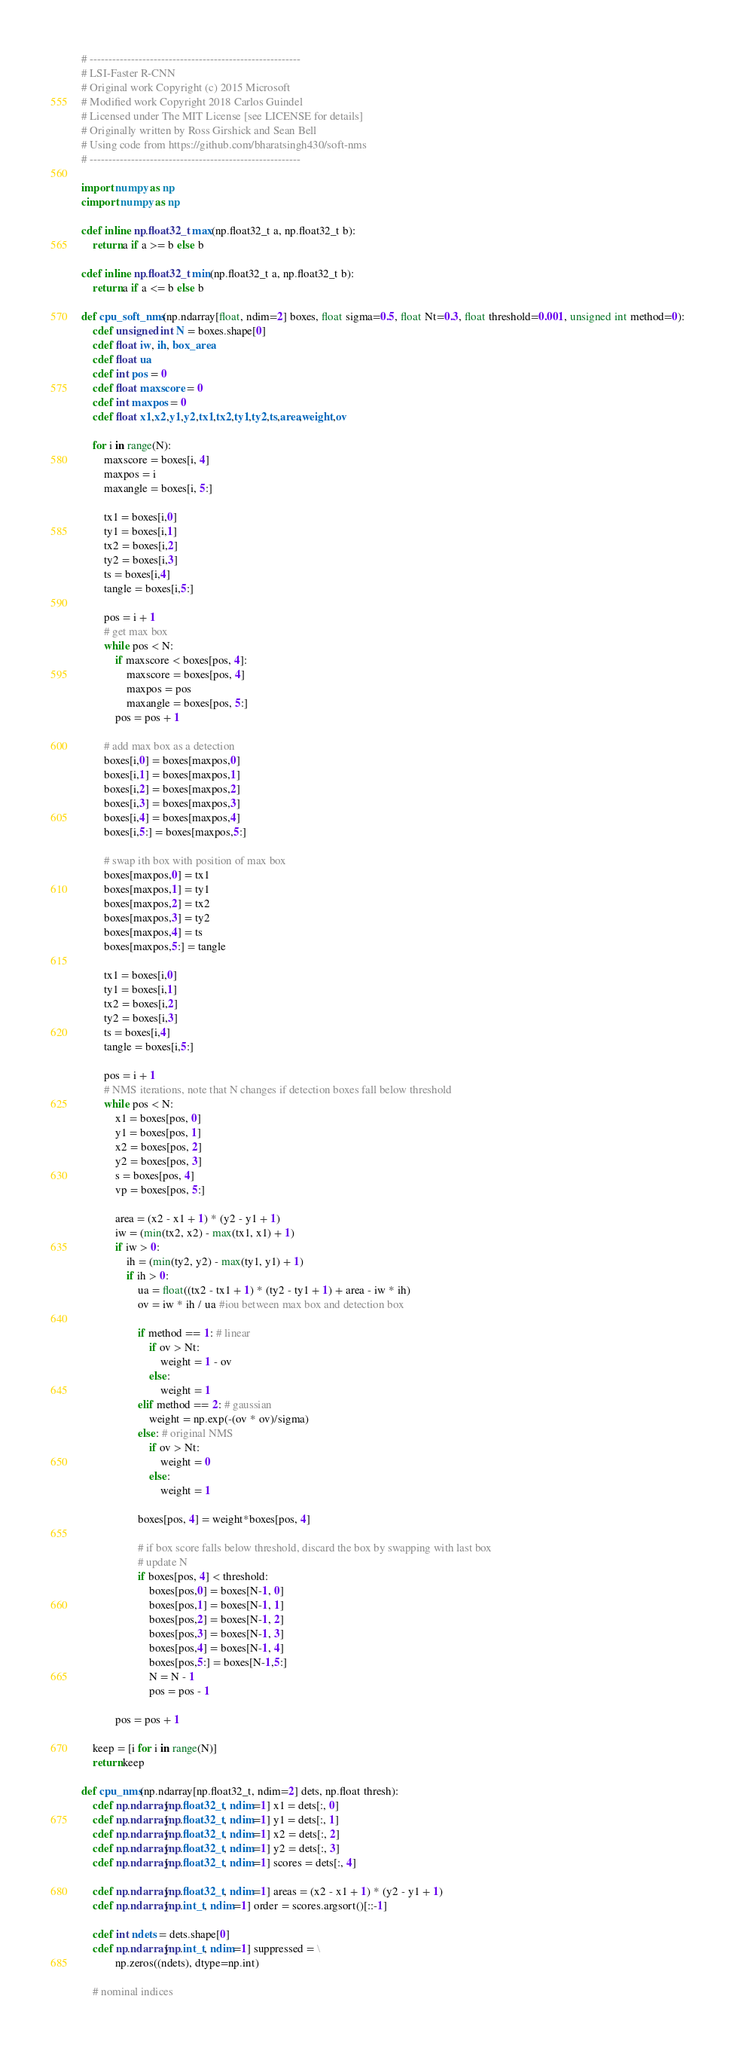<code> <loc_0><loc_0><loc_500><loc_500><_Cython_># --------------------------------------------------------
# LSI-Faster R-CNN
# Original work Copyright (c) 2015 Microsoft
# Modified work Copyright 2018 Carlos Guindel
# Licensed under The MIT License [see LICENSE for details]
# Originally written by Ross Girshick and Sean Bell
# Using code from https://github.com/bharatsingh430/soft-nms
# --------------------------------------------------------

import numpy as np
cimport numpy as np

cdef inline np.float32_t max(np.float32_t a, np.float32_t b):
    return a if a >= b else b

cdef inline np.float32_t min(np.float32_t a, np.float32_t b):
    return a if a <= b else b

def cpu_soft_nms(np.ndarray[float, ndim=2] boxes, float sigma=0.5, float Nt=0.3, float threshold=0.001, unsigned int method=0):
    cdef unsigned int N = boxes.shape[0]
    cdef float iw, ih, box_area
    cdef float ua
    cdef int pos = 0
    cdef float maxscore = 0
    cdef int maxpos = 0
    cdef float x1,x2,y1,y2,tx1,tx2,ty1,ty2,ts,area,weight,ov

    for i in range(N):
        maxscore = boxes[i, 4]
        maxpos = i
        maxangle = boxes[i, 5:]

        tx1 = boxes[i,0]
        ty1 = boxes[i,1]
        tx2 = boxes[i,2]
        ty2 = boxes[i,3]
        ts = boxes[i,4]
        tangle = boxes[i,5:]

        pos = i + 1
        # get max box
        while pos < N:
            if maxscore < boxes[pos, 4]:
                maxscore = boxes[pos, 4]
                maxpos = pos
                maxangle = boxes[pos, 5:]
            pos = pos + 1

        # add max box as a detection
        boxes[i,0] = boxes[maxpos,0]
        boxes[i,1] = boxes[maxpos,1]
        boxes[i,2] = boxes[maxpos,2]
        boxes[i,3] = boxes[maxpos,3]
        boxes[i,4] = boxes[maxpos,4]
        boxes[i,5:] = boxes[maxpos,5:]

        # swap ith box with position of max box
        boxes[maxpos,0] = tx1
        boxes[maxpos,1] = ty1
        boxes[maxpos,2] = tx2
        boxes[maxpos,3] = ty2
        boxes[maxpos,4] = ts
        boxes[maxpos,5:] = tangle

        tx1 = boxes[i,0]
        ty1 = boxes[i,1]
        tx2 = boxes[i,2]
        ty2 = boxes[i,3]
        ts = boxes[i,4]
        tangle = boxes[i,5:]

        pos = i + 1
        # NMS iterations, note that N changes if detection boxes fall below threshold
        while pos < N:
            x1 = boxes[pos, 0]
            y1 = boxes[pos, 1]
            x2 = boxes[pos, 2]
            y2 = boxes[pos, 3]
            s = boxes[pos, 4]
            vp = boxes[pos, 5:]

            area = (x2 - x1 + 1) * (y2 - y1 + 1)
            iw = (min(tx2, x2) - max(tx1, x1) + 1)
            if iw > 0:
                ih = (min(ty2, y2) - max(ty1, y1) + 1)
                if ih > 0:
                    ua = float((tx2 - tx1 + 1) * (ty2 - ty1 + 1) + area - iw * ih)
                    ov = iw * ih / ua #iou between max box and detection box

                    if method == 1: # linear
                        if ov > Nt:
                            weight = 1 - ov
                        else:
                            weight = 1
                    elif method == 2: # gaussian
                        weight = np.exp(-(ov * ov)/sigma)
                    else: # original NMS
                        if ov > Nt:
                            weight = 0
                        else:
                            weight = 1

                    boxes[pos, 4] = weight*boxes[pos, 4]

                    # if box score falls below threshold, discard the box by swapping with last box
                    # update N
                    if boxes[pos, 4] < threshold:
                        boxes[pos,0] = boxes[N-1, 0]
                        boxes[pos,1] = boxes[N-1, 1]
                        boxes[pos,2] = boxes[N-1, 2]
                        boxes[pos,3] = boxes[N-1, 3]
                        boxes[pos,4] = boxes[N-1, 4]
                        boxes[pos,5:] = boxes[N-1,5:]
                        N = N - 1
                        pos = pos - 1

            pos = pos + 1

    keep = [i for i in range(N)]
    return keep

def cpu_nms(np.ndarray[np.float32_t, ndim=2] dets, np.float thresh):
    cdef np.ndarray[np.float32_t, ndim=1] x1 = dets[:, 0]
    cdef np.ndarray[np.float32_t, ndim=1] y1 = dets[:, 1]
    cdef np.ndarray[np.float32_t, ndim=1] x2 = dets[:, 2]
    cdef np.ndarray[np.float32_t, ndim=1] y2 = dets[:, 3]
    cdef np.ndarray[np.float32_t, ndim=1] scores = dets[:, 4]

    cdef np.ndarray[np.float32_t, ndim=1] areas = (x2 - x1 + 1) * (y2 - y1 + 1)
    cdef np.ndarray[np.int_t, ndim=1] order = scores.argsort()[::-1]

    cdef int ndets = dets.shape[0]
    cdef np.ndarray[np.int_t, ndim=1] suppressed = \
            np.zeros((ndets), dtype=np.int)

    # nominal indices</code> 